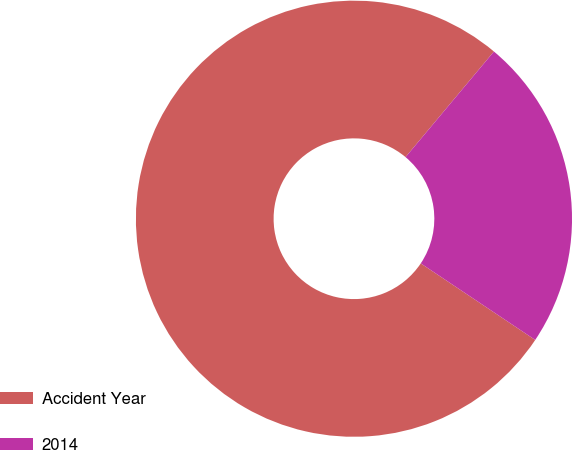Convert chart. <chart><loc_0><loc_0><loc_500><loc_500><pie_chart><fcel>Accident Year<fcel>2014<nl><fcel>76.71%<fcel>23.29%<nl></chart> 